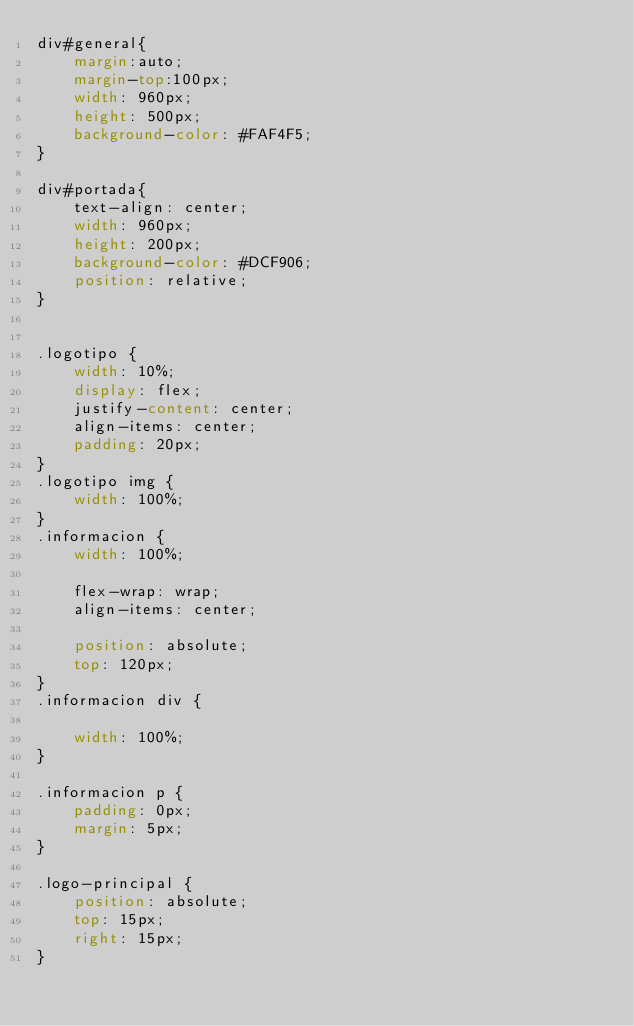<code> <loc_0><loc_0><loc_500><loc_500><_CSS_>div#general{
    margin:auto;
    margin-top:100px;
    width: 960px;
    height: 500px;
    background-color: #FAF4F5;
}

div#portada{
    text-align: center;
    width: 960px;
    height: 200px;
    background-color: #DCF906;
    position: relative;
}


.logotipo {
    width: 10%;
    display: flex;
    justify-content: center;
    align-items: center;
    padding: 20px;
}
.logotipo img {
    width: 100%;
}
.informacion {
    width: 100%;
   
    flex-wrap: wrap;
    align-items: center;

    position: absolute;
    top: 120px;
}
.informacion div {

    width: 100%;
}

.informacion p {
    padding: 0px;
    margin: 5px;
}

.logo-principal {
    position: absolute;
    top: 15px;
    right: 15px;
}</code> 